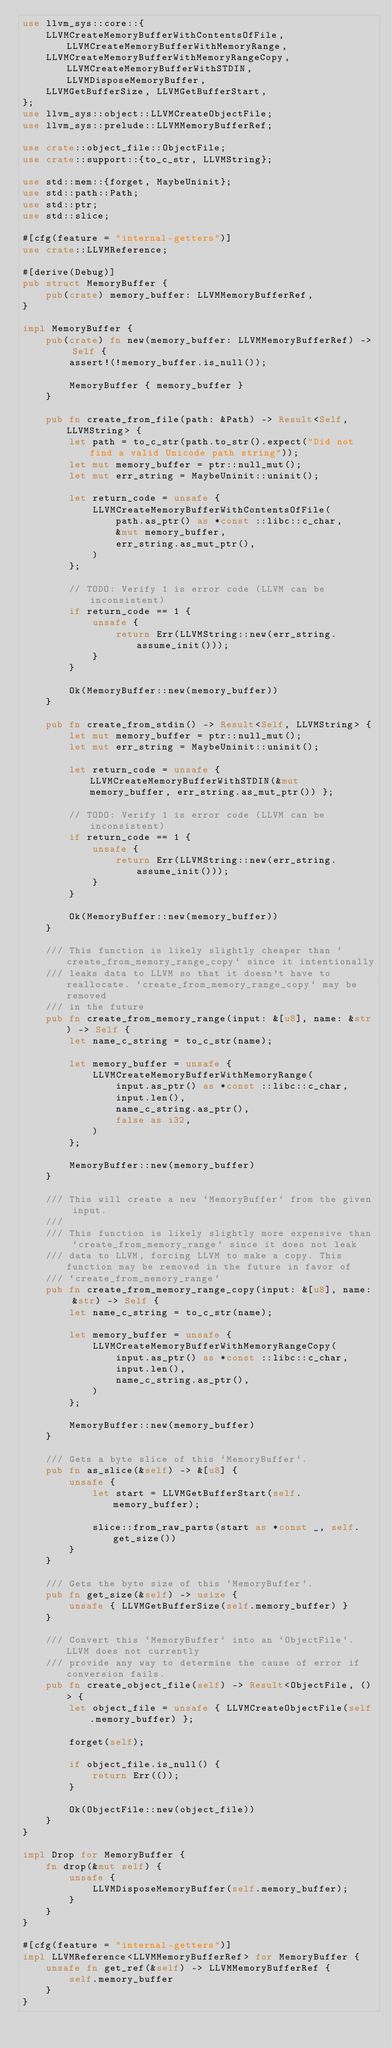<code> <loc_0><loc_0><loc_500><loc_500><_Rust_>use llvm_sys::core::{
    LLVMCreateMemoryBufferWithContentsOfFile, LLVMCreateMemoryBufferWithMemoryRange,
    LLVMCreateMemoryBufferWithMemoryRangeCopy, LLVMCreateMemoryBufferWithSTDIN, LLVMDisposeMemoryBuffer,
    LLVMGetBufferSize, LLVMGetBufferStart,
};
use llvm_sys::object::LLVMCreateObjectFile;
use llvm_sys::prelude::LLVMMemoryBufferRef;

use crate::object_file::ObjectFile;
use crate::support::{to_c_str, LLVMString};

use std::mem::{forget, MaybeUninit};
use std::path::Path;
use std::ptr;
use std::slice;

#[cfg(feature = "internal-getters")]
use crate::LLVMReference;

#[derive(Debug)]
pub struct MemoryBuffer {
    pub(crate) memory_buffer: LLVMMemoryBufferRef,
}

impl MemoryBuffer {
    pub(crate) fn new(memory_buffer: LLVMMemoryBufferRef) -> Self {
        assert!(!memory_buffer.is_null());

        MemoryBuffer { memory_buffer }
    }

    pub fn create_from_file(path: &Path) -> Result<Self, LLVMString> {
        let path = to_c_str(path.to_str().expect("Did not find a valid Unicode path string"));
        let mut memory_buffer = ptr::null_mut();
        let mut err_string = MaybeUninit::uninit();

        let return_code = unsafe {
            LLVMCreateMemoryBufferWithContentsOfFile(
                path.as_ptr() as *const ::libc::c_char,
                &mut memory_buffer,
                err_string.as_mut_ptr(),
            )
        };

        // TODO: Verify 1 is error code (LLVM can be inconsistent)
        if return_code == 1 {
            unsafe {
                return Err(LLVMString::new(err_string.assume_init()));
            }
        }

        Ok(MemoryBuffer::new(memory_buffer))
    }

    pub fn create_from_stdin() -> Result<Self, LLVMString> {
        let mut memory_buffer = ptr::null_mut();
        let mut err_string = MaybeUninit::uninit();

        let return_code = unsafe { LLVMCreateMemoryBufferWithSTDIN(&mut memory_buffer, err_string.as_mut_ptr()) };

        // TODO: Verify 1 is error code (LLVM can be inconsistent)
        if return_code == 1 {
            unsafe {
                return Err(LLVMString::new(err_string.assume_init()));
            }
        }

        Ok(MemoryBuffer::new(memory_buffer))
    }

    /// This function is likely slightly cheaper than `create_from_memory_range_copy` since it intentionally
    /// leaks data to LLVM so that it doesn't have to reallocate. `create_from_memory_range_copy` may be removed
    /// in the future
    pub fn create_from_memory_range(input: &[u8], name: &str) -> Self {
        let name_c_string = to_c_str(name);

        let memory_buffer = unsafe {
            LLVMCreateMemoryBufferWithMemoryRange(
                input.as_ptr() as *const ::libc::c_char,
                input.len(),
                name_c_string.as_ptr(),
                false as i32,
            )
        };

        MemoryBuffer::new(memory_buffer)
    }

    /// This will create a new `MemoryBuffer` from the given input.
    ///
    /// This function is likely slightly more expensive than `create_from_memory_range` since it does not leak
    /// data to LLVM, forcing LLVM to make a copy. This function may be removed in the future in favor of
    /// `create_from_memory_range`
    pub fn create_from_memory_range_copy(input: &[u8], name: &str) -> Self {
        let name_c_string = to_c_str(name);

        let memory_buffer = unsafe {
            LLVMCreateMemoryBufferWithMemoryRangeCopy(
                input.as_ptr() as *const ::libc::c_char,
                input.len(),
                name_c_string.as_ptr(),
            )
        };

        MemoryBuffer::new(memory_buffer)
    }

    /// Gets a byte slice of this `MemoryBuffer`.
    pub fn as_slice(&self) -> &[u8] {
        unsafe {
            let start = LLVMGetBufferStart(self.memory_buffer);

            slice::from_raw_parts(start as *const _, self.get_size())
        }
    }

    /// Gets the byte size of this `MemoryBuffer`.
    pub fn get_size(&self) -> usize {
        unsafe { LLVMGetBufferSize(self.memory_buffer) }
    }

    /// Convert this `MemoryBuffer` into an `ObjectFile`. LLVM does not currently
    /// provide any way to determine the cause of error if conversion fails.
    pub fn create_object_file(self) -> Result<ObjectFile, ()> {
        let object_file = unsafe { LLVMCreateObjectFile(self.memory_buffer) };

        forget(self);

        if object_file.is_null() {
            return Err(());
        }

        Ok(ObjectFile::new(object_file))
    }
}

impl Drop for MemoryBuffer {
    fn drop(&mut self) {
        unsafe {
            LLVMDisposeMemoryBuffer(self.memory_buffer);
        }
    }
}

#[cfg(feature = "internal-getters")]
impl LLVMReference<LLVMMemoryBufferRef> for MemoryBuffer {
    unsafe fn get_ref(&self) -> LLVMMemoryBufferRef {
        self.memory_buffer
    }
}
</code> 